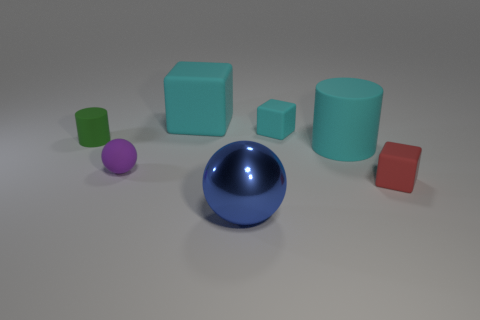Can you tell me about the lighting in this scene? The scene is softly lit from above, casting gentle shadows beneath the objects. The lighting appears uniform, likely from a wide light source, creating a diffused effect that softens the edges of the shapes and enhances the objects' three-dimensional qualities. 